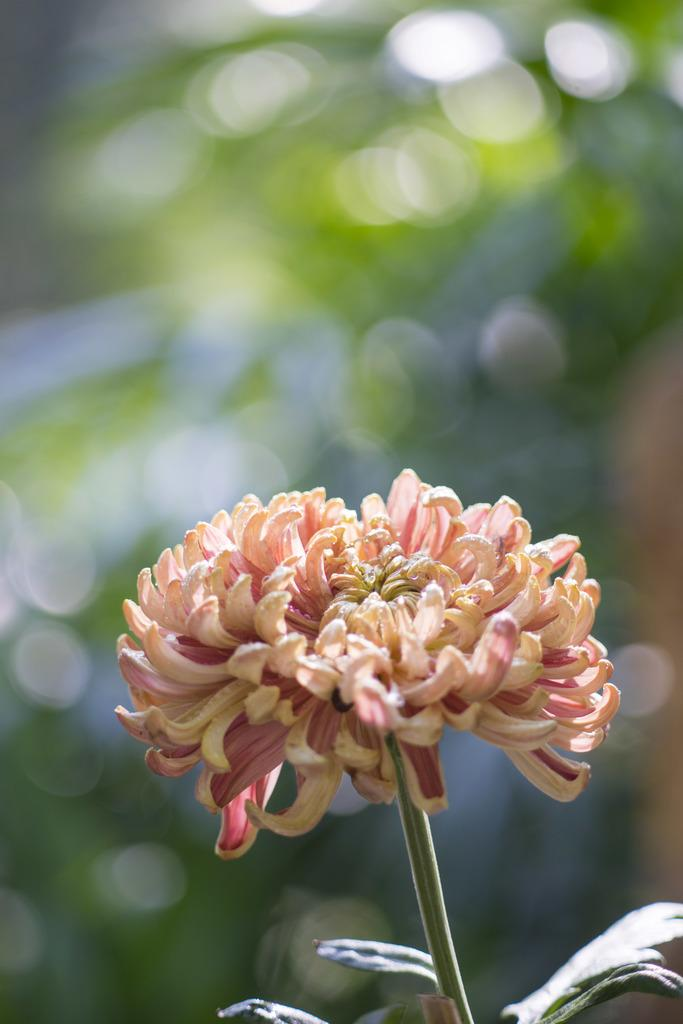What is the main subject of the image? There is a flower in the image. What part of the flower can be seen in the image? The plant has multiple leaves. What is the color of the leaves? The leaves are green in color. How many lizards can be seen climbing on the flower in the image? There are no lizards present in the image; it features a flower with multiple green leaves. What is the flower using to attach itself to the moon in the image? There is no moon present in the image, and the flower is not attached to anything. 